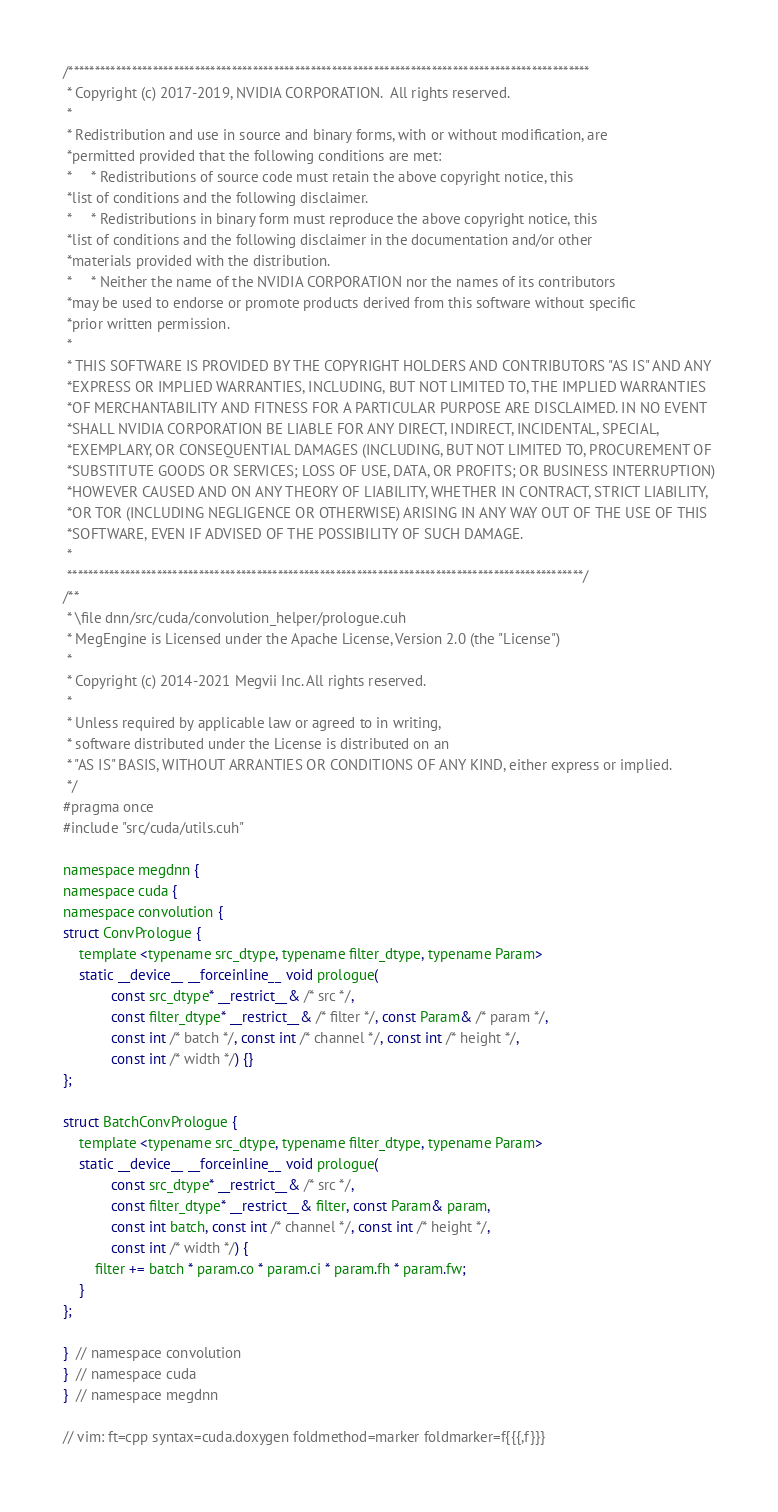Convert code to text. <code><loc_0><loc_0><loc_500><loc_500><_Cuda_>/***************************************************************************************************
 * Copyright (c) 2017-2019, NVIDIA CORPORATION.  All rights reserved.
 *
 * Redistribution and use in source and binary forms, with or without modification, are
 *permitted provided that the following conditions are met:
 *     * Redistributions of source code must retain the above copyright notice, this
 *list of conditions and the following disclaimer.
 *     * Redistributions in binary form must reproduce the above copyright notice, this
 *list of conditions and the following disclaimer in the documentation and/or other
 *materials provided with the distribution.
 *     * Neither the name of the NVIDIA CORPORATION nor the names of its contributors
 *may be used to endorse or promote products derived from this software without specific
 *prior written permission.
 *
 * THIS SOFTWARE IS PROVIDED BY THE COPYRIGHT HOLDERS AND CONTRIBUTORS "AS IS" AND ANY
 *EXPRESS OR IMPLIED WARRANTIES, INCLUDING, BUT NOT LIMITED TO, THE IMPLIED WARRANTIES
 *OF MERCHANTABILITY AND FITNESS FOR A PARTICULAR PURPOSE ARE DISCLAIMED. IN NO EVENT
 *SHALL NVIDIA CORPORATION BE LIABLE FOR ANY DIRECT, INDIRECT, INCIDENTAL, SPECIAL,
 *EXEMPLARY, OR CONSEQUENTIAL DAMAGES (INCLUDING, BUT NOT LIMITED TO, PROCUREMENT OF
 *SUBSTITUTE GOODS OR SERVICES; LOSS OF USE, DATA, OR PROFITS; OR BUSINESS INTERRUPTION)
 *HOWEVER CAUSED AND ON ANY THEORY OF LIABILITY, WHETHER IN CONTRACT, STRICT LIABILITY,
 *OR TOR (INCLUDING NEGLIGENCE OR OTHERWISE) ARISING IN ANY WAY OUT OF THE USE OF THIS
 *SOFTWARE, EVEN IF ADVISED OF THE POSSIBILITY OF SUCH DAMAGE.
 *
 **************************************************************************************************/
/**
 * \file dnn/src/cuda/convolution_helper/prologue.cuh
 * MegEngine is Licensed under the Apache License, Version 2.0 (the "License")
 *
 * Copyright (c) 2014-2021 Megvii Inc. All rights reserved.
 *
 * Unless required by applicable law or agreed to in writing,
 * software distributed under the License is distributed on an
 * "AS IS" BASIS, WITHOUT ARRANTIES OR CONDITIONS OF ANY KIND, either express or implied.
 */
#pragma once
#include "src/cuda/utils.cuh"

namespace megdnn {
namespace cuda {
namespace convolution {
struct ConvPrologue {
    template <typename src_dtype, typename filter_dtype, typename Param>
    static __device__ __forceinline__ void prologue(
            const src_dtype* __restrict__& /* src */,
            const filter_dtype* __restrict__& /* filter */, const Param& /* param */,
            const int /* batch */, const int /* channel */, const int /* height */,
            const int /* width */) {}
};

struct BatchConvPrologue {
    template <typename src_dtype, typename filter_dtype, typename Param>
    static __device__ __forceinline__ void prologue(
            const src_dtype* __restrict__& /* src */,
            const filter_dtype* __restrict__& filter, const Param& param,
            const int batch, const int /* channel */, const int /* height */,
            const int /* width */) {
        filter += batch * param.co * param.ci * param.fh * param.fw;
    }
};

}  // namespace convolution
}  // namespace cuda
}  // namespace megdnn

// vim: ft=cpp syntax=cuda.doxygen foldmethod=marker foldmarker=f{{{,f}}}
</code> 